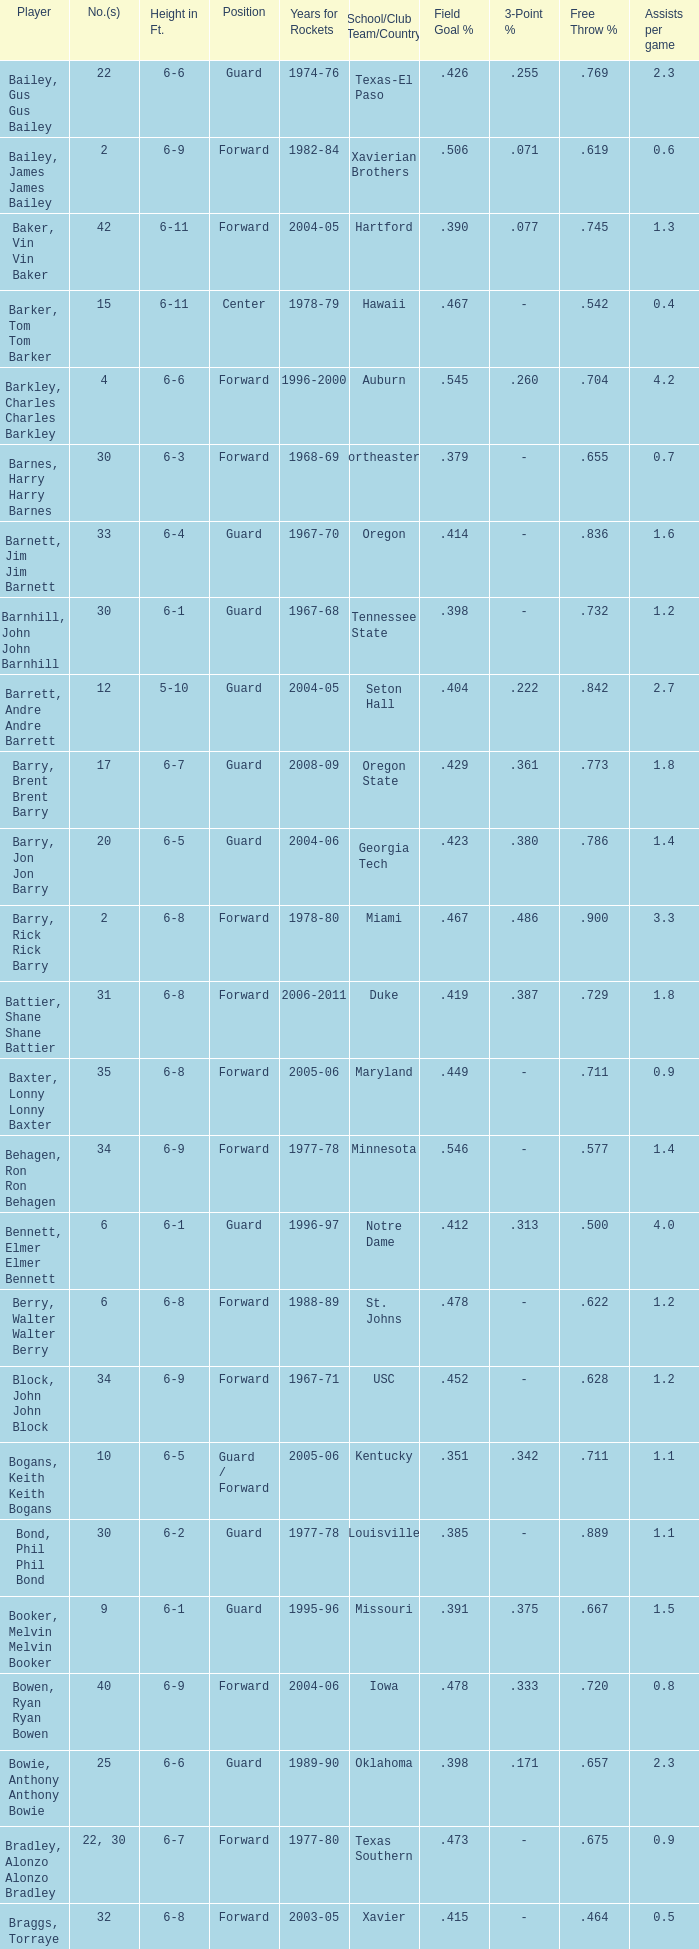What position is number 35 whose height is 6-6? Forward. 